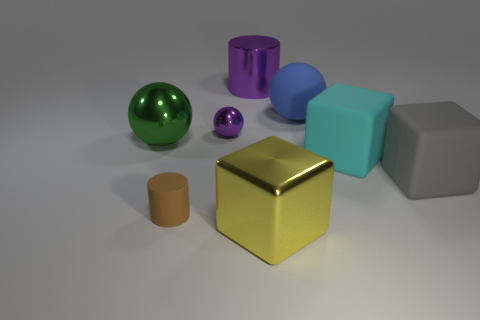Add 1 big metallic cylinders. How many objects exist? 9 Subtract all cylinders. How many objects are left? 6 Add 3 cyan balls. How many cyan balls exist? 3 Subtract 0 cyan balls. How many objects are left? 8 Subtract all small cylinders. Subtract all shiny cubes. How many objects are left? 6 Add 3 large cyan rubber cubes. How many large cyan rubber cubes are left? 4 